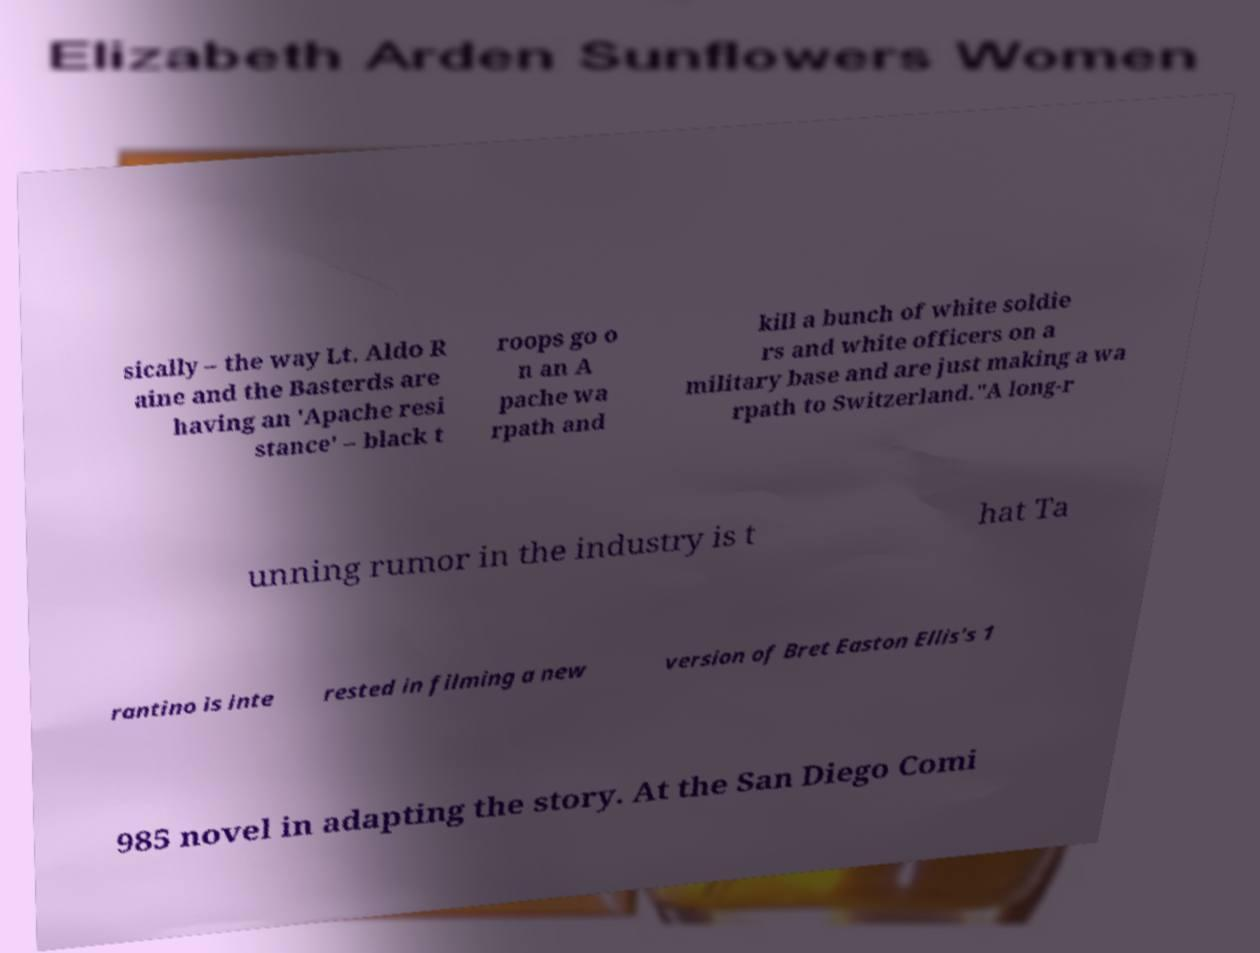There's text embedded in this image that I need extracted. Can you transcribe it verbatim? sically – the way Lt. Aldo R aine and the Basterds are having an 'Apache resi stance' – black t roops go o n an A pache wa rpath and kill a bunch of white soldie rs and white officers on a military base and are just making a wa rpath to Switzerland."A long-r unning rumor in the industry is t hat Ta rantino is inte rested in filming a new version of Bret Easton Ellis's 1 985 novel in adapting the story. At the San Diego Comi 